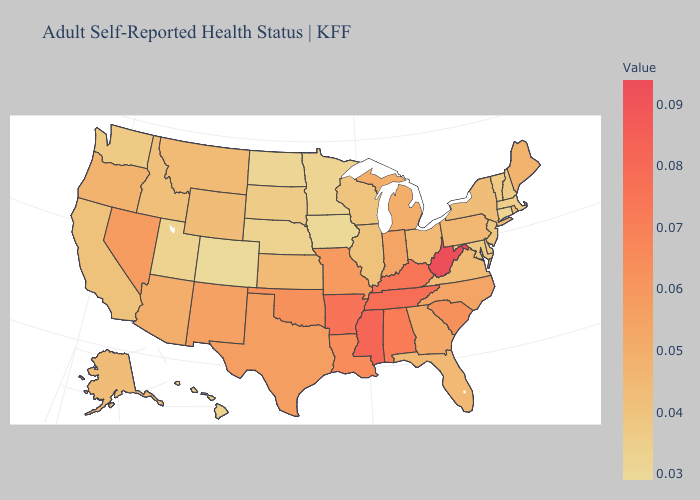Does Wyoming have the highest value in the USA?
Short answer required. No. Among the states that border Washington , which have the highest value?
Answer briefly. Oregon. 